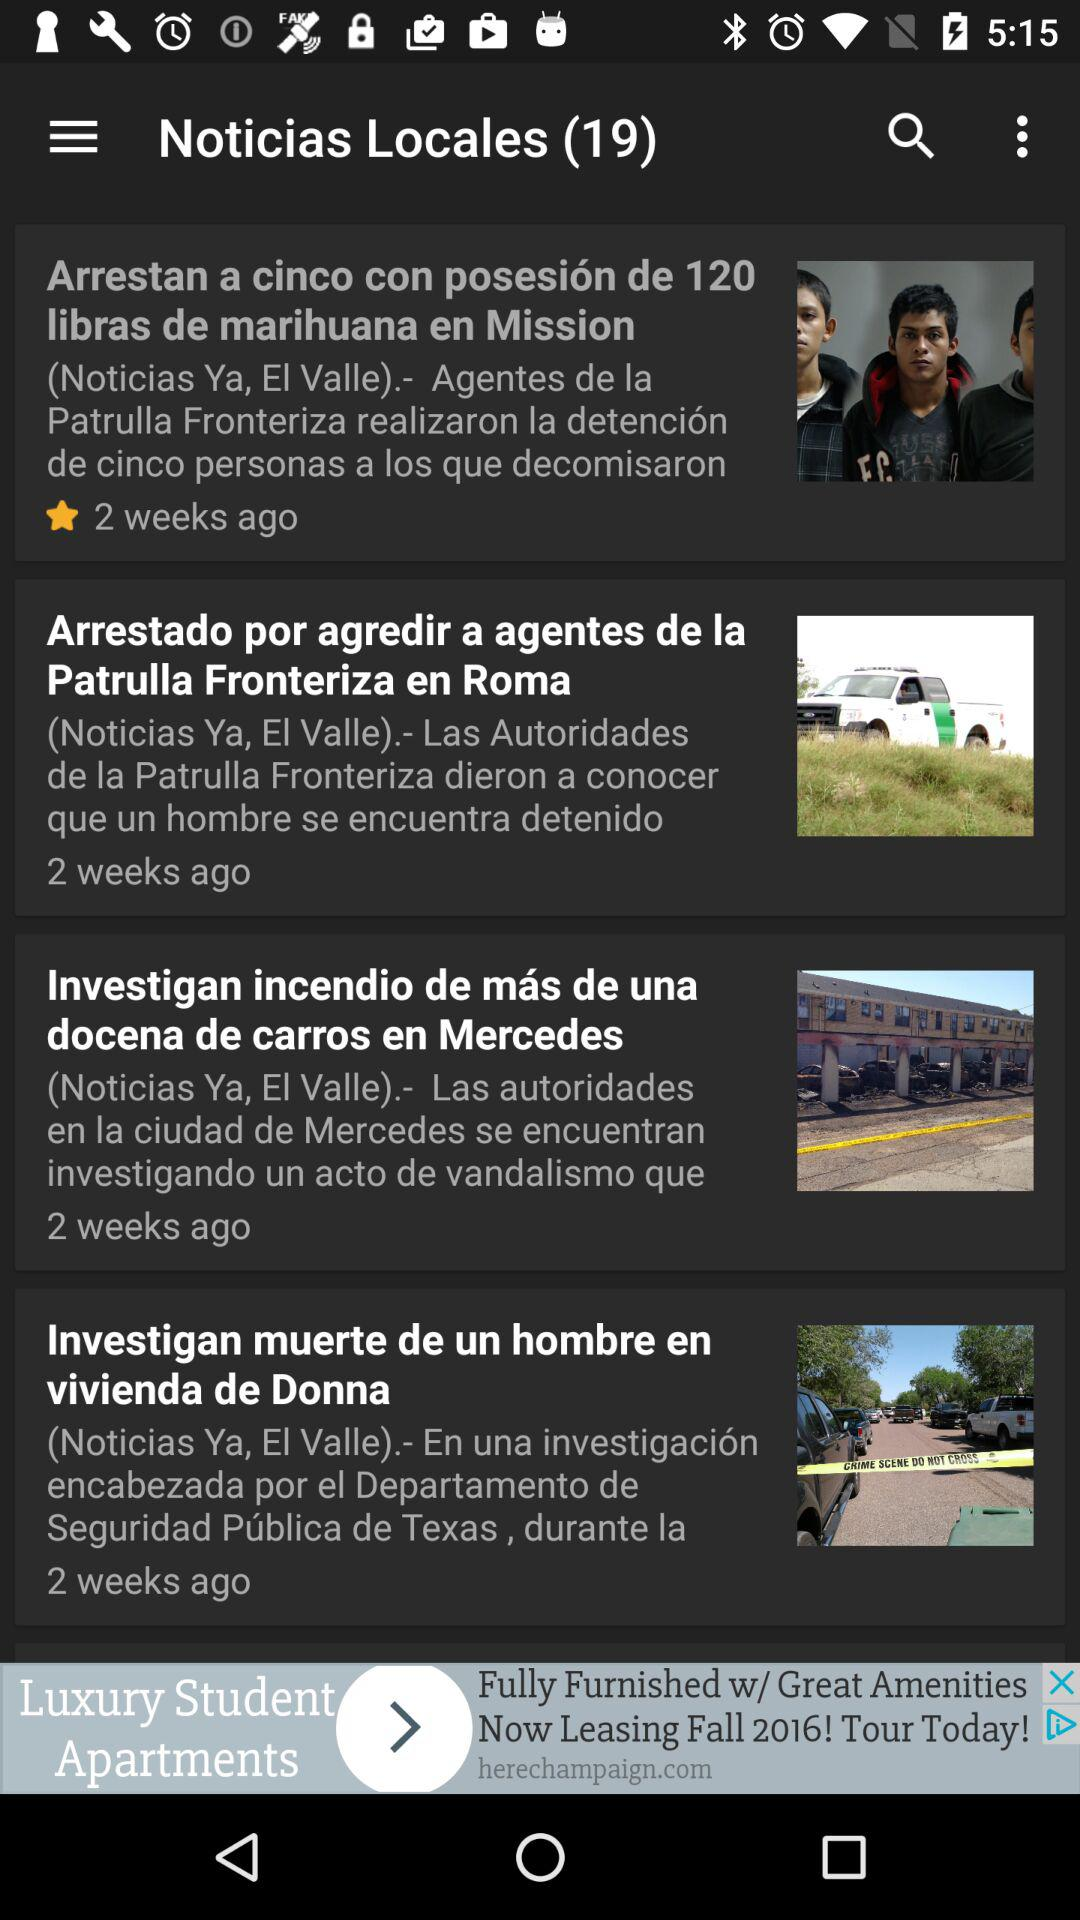How many stories are there in the news feed?
Answer the question using a single word or phrase. 4 